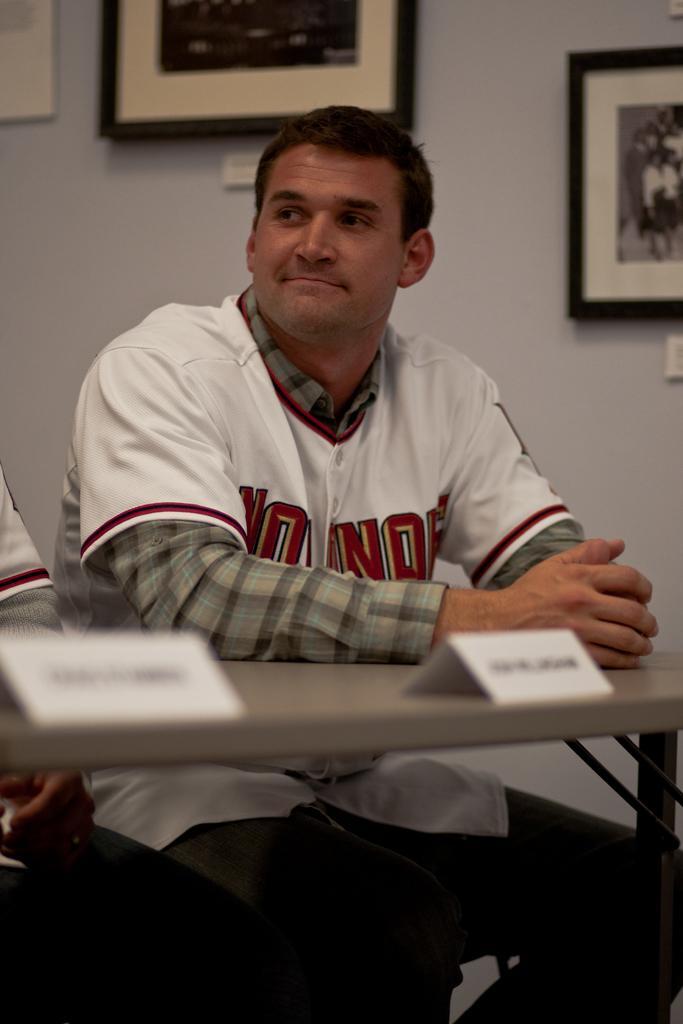Describe this image in one or two sentences. A man wearing a white t shirt is sitting. In front of him there is a table. On the table there are some name boards. In the background there is a wall with a photo frame. 